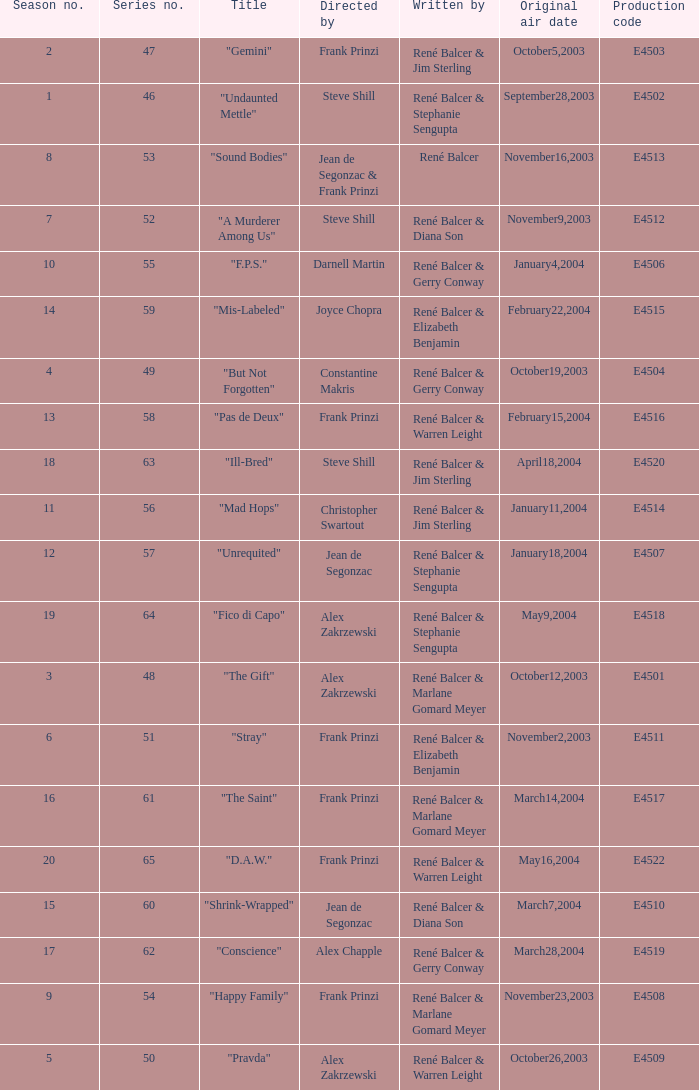What episode number in the season is titled "stray"? 6.0. 